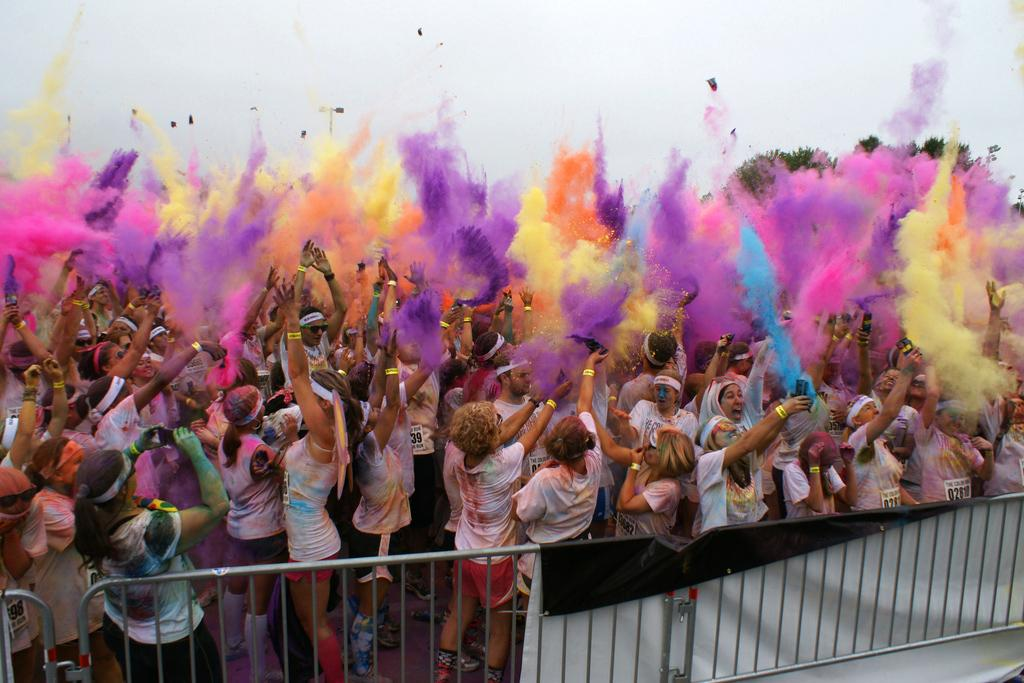How many people are in the group in the image? There is a group of people in the image, but the exact number is not specified. What are some people in the group holding? Some people in the group are holding mobiles. What can be seen in the foreground of the image? Metal rods are visible in the foreground of the image. What colors are present in the image? There are colors present in the image, but the specific colors are not mentioned. What type of vegetation is visible in the image? Trees are visible in the image. What type of toothbrush is being used by the person in the image? There is no toothbrush present in the image. What type of gate can be seen in the image? There is no gate present in the image. 